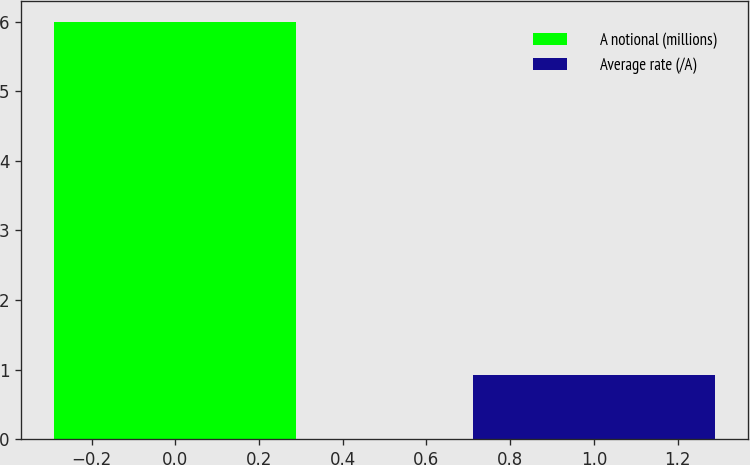Convert chart. <chart><loc_0><loc_0><loc_500><loc_500><bar_chart><fcel>A notional (millions)<fcel>Average rate (/A)<nl><fcel>6<fcel>0.92<nl></chart> 